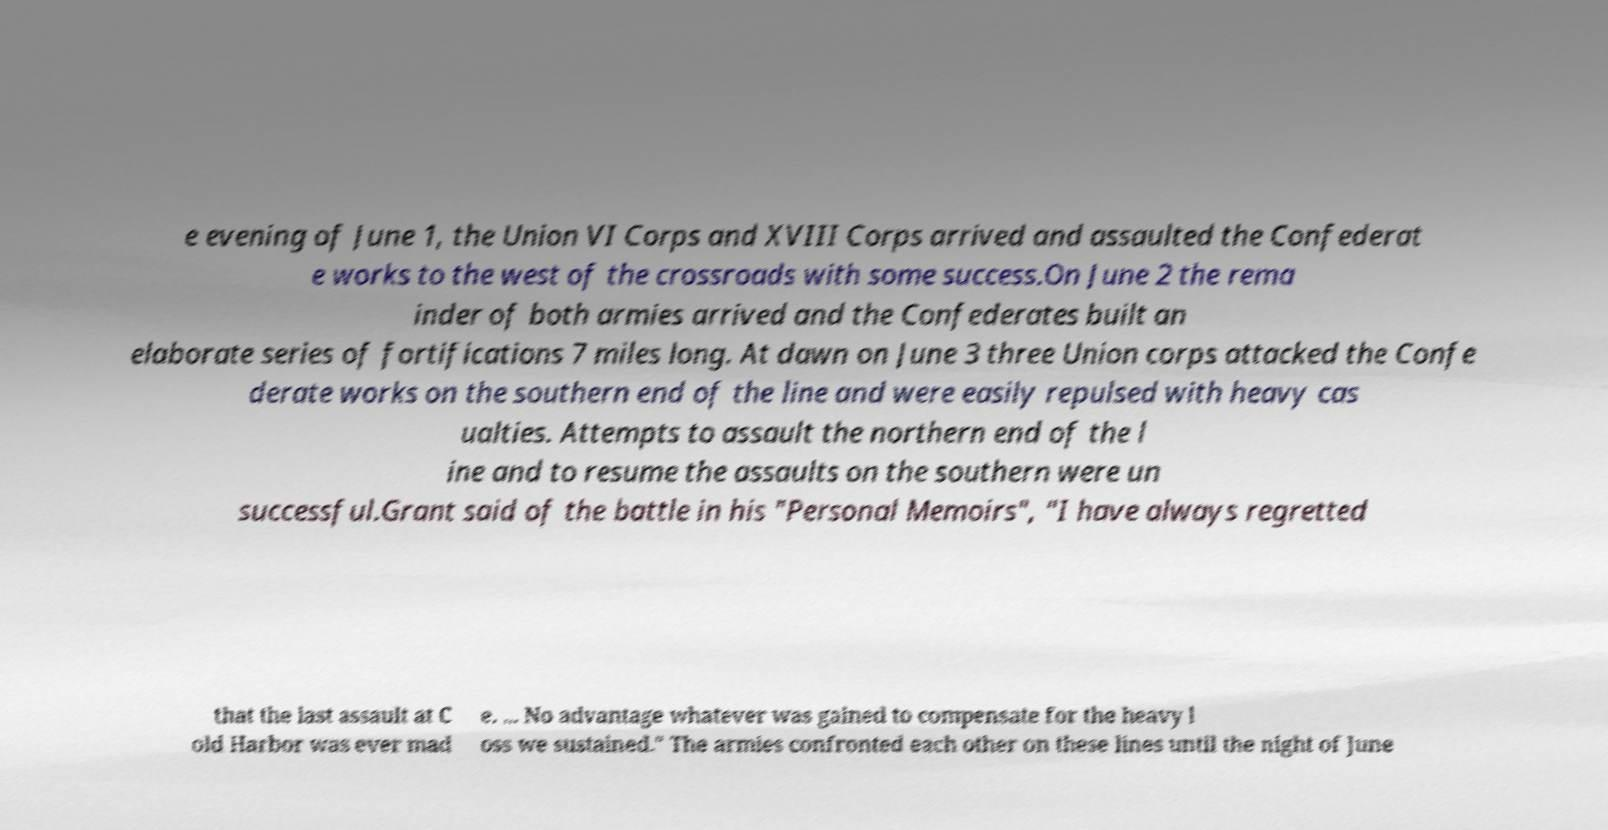Could you assist in decoding the text presented in this image and type it out clearly? e evening of June 1, the Union VI Corps and XVIII Corps arrived and assaulted the Confederat e works to the west of the crossroads with some success.On June 2 the rema inder of both armies arrived and the Confederates built an elaborate series of fortifications 7 miles long. At dawn on June 3 three Union corps attacked the Confe derate works on the southern end of the line and were easily repulsed with heavy cas ualties. Attempts to assault the northern end of the l ine and to resume the assaults on the southern were un successful.Grant said of the battle in his "Personal Memoirs", "I have always regretted that the last assault at C old Harbor was ever mad e. ... No advantage whatever was gained to compensate for the heavy l oss we sustained." The armies confronted each other on these lines until the night of June 